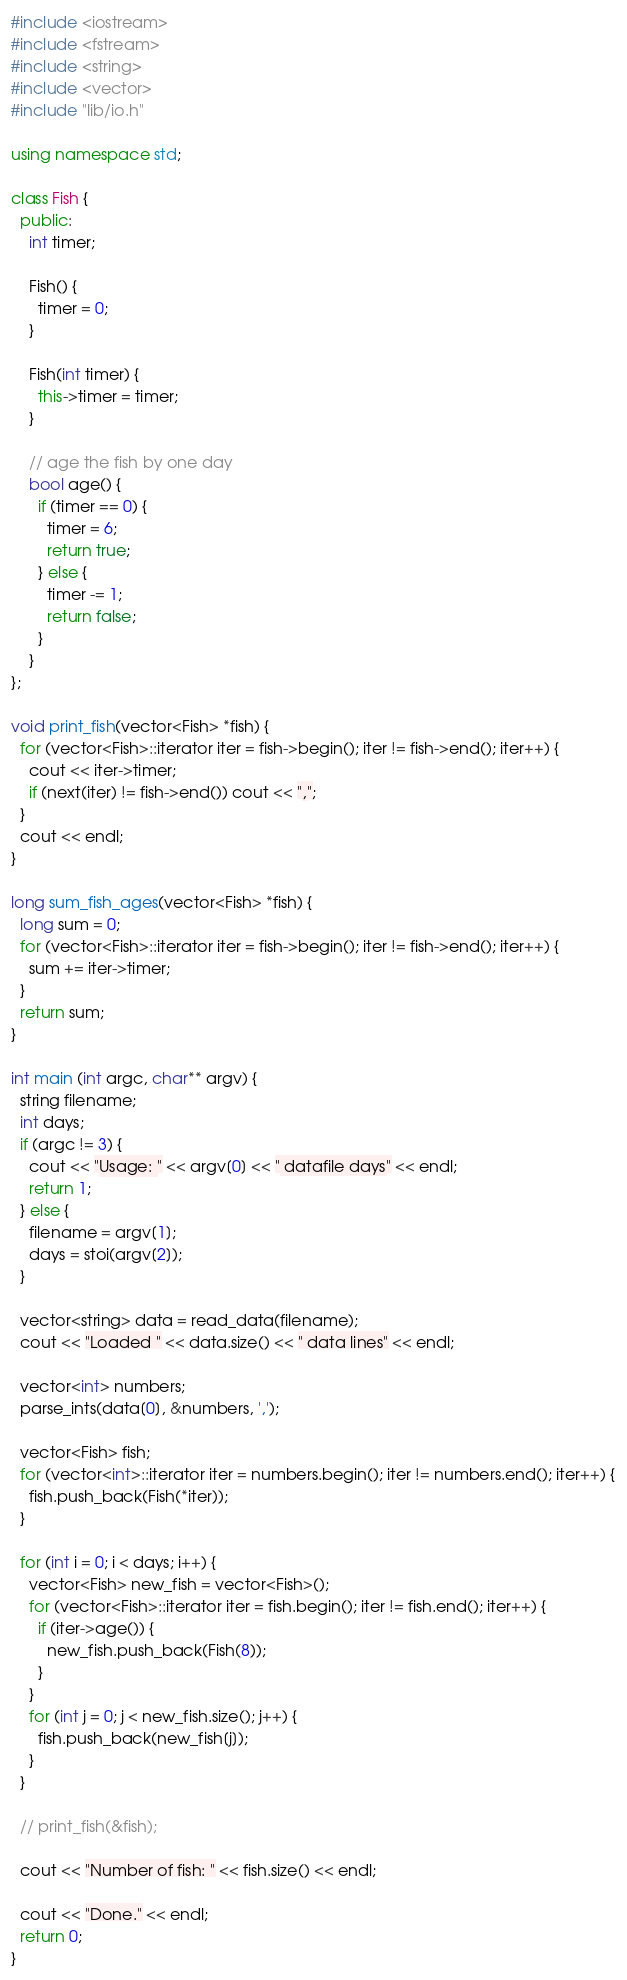Convert code to text. <code><loc_0><loc_0><loc_500><loc_500><_C++_>#include <iostream>
#include <fstream>
#include <string>
#include <vector>
#include "lib/io.h"

using namespace std;

class Fish {
  public:
    int timer;

    Fish() {
      timer = 0;
    }

    Fish(int timer) {
      this->timer = timer;
    }

    // age the fish by one day
    bool age() {
      if (timer == 0) {
        timer = 6;
        return true;
      } else {
        timer -= 1;
        return false;
      }
    }
};

void print_fish(vector<Fish> *fish) {
  for (vector<Fish>::iterator iter = fish->begin(); iter != fish->end(); iter++) {
    cout << iter->timer;
    if (next(iter) != fish->end()) cout << ",";
  }
  cout << endl;
}

long sum_fish_ages(vector<Fish> *fish) {
  long sum = 0;
  for (vector<Fish>::iterator iter = fish->begin(); iter != fish->end(); iter++) {
    sum += iter->timer;
  }
  return sum;
}

int main (int argc, char** argv) {
  string filename;
  int days;
  if (argc != 3) {
    cout << "Usage: " << argv[0] << " datafile days" << endl;
    return 1;
  } else {
    filename = argv[1];
    days = stoi(argv[2]);
  }

  vector<string> data = read_data(filename);
  cout << "Loaded " << data.size() << " data lines" << endl;

  vector<int> numbers;
  parse_ints(data[0], &numbers, ',');

  vector<Fish> fish;
  for (vector<int>::iterator iter = numbers.begin(); iter != numbers.end(); iter++) {
    fish.push_back(Fish(*iter));
  }

  for (int i = 0; i < days; i++) {
    vector<Fish> new_fish = vector<Fish>();
    for (vector<Fish>::iterator iter = fish.begin(); iter != fish.end(); iter++) {
      if (iter->age()) {
        new_fish.push_back(Fish(8));
      }
    }
    for (int j = 0; j < new_fish.size(); j++) {
      fish.push_back(new_fish[j]);
    }
  }

  // print_fish(&fish); 

  cout << "Number of fish: " << fish.size() << endl;

  cout << "Done." << endl;
  return 0;
}
</code> 